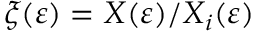Convert formula to latex. <formula><loc_0><loc_0><loc_500><loc_500>\xi ( \varepsilon ) = X ( \varepsilon ) / X _ { i } ( \varepsilon )</formula> 